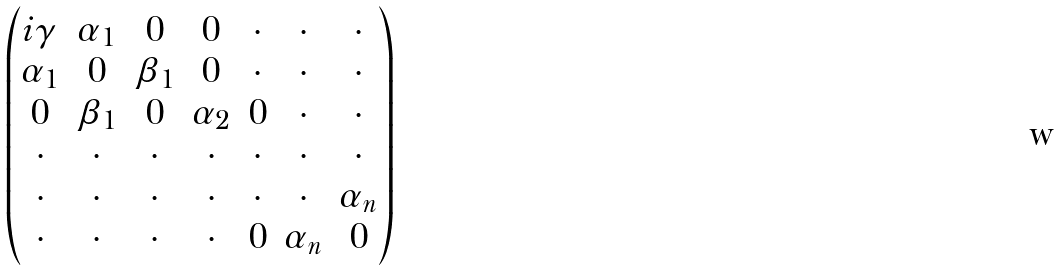Convert formula to latex. <formula><loc_0><loc_0><loc_500><loc_500>\begin{pmatrix} i \gamma & \alpha _ { 1 } & 0 & 0 & \cdot & \cdot & \cdot \\ \alpha _ { 1 } & 0 & \beta _ { 1 } & 0 & \cdot & \cdot & \cdot \\ 0 & \beta _ { 1 } & 0 & \alpha _ { 2 } & 0 & \cdot & \cdot \\ \cdot & \cdot & \cdot & \cdot & \cdot & \cdot & \cdot \\ \cdot & \cdot & \cdot & \cdot & \cdot & \cdot & \alpha _ { n } \\ \cdot & \cdot & \cdot & \cdot & 0 & \alpha _ { n } & 0 \end{pmatrix}</formula> 